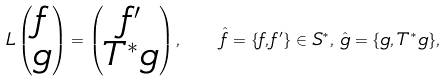<formula> <loc_0><loc_0><loc_500><loc_500>L \begin{pmatrix} f \\ g \end{pmatrix} = \begin{pmatrix} f ^ { \prime } \\ T ^ { * } g \end{pmatrix} , \quad \hat { f } = \{ f , f ^ { \prime } \} \in S ^ { * } , \, \hat { g } = \{ g , T ^ { * } g \} ,</formula> 